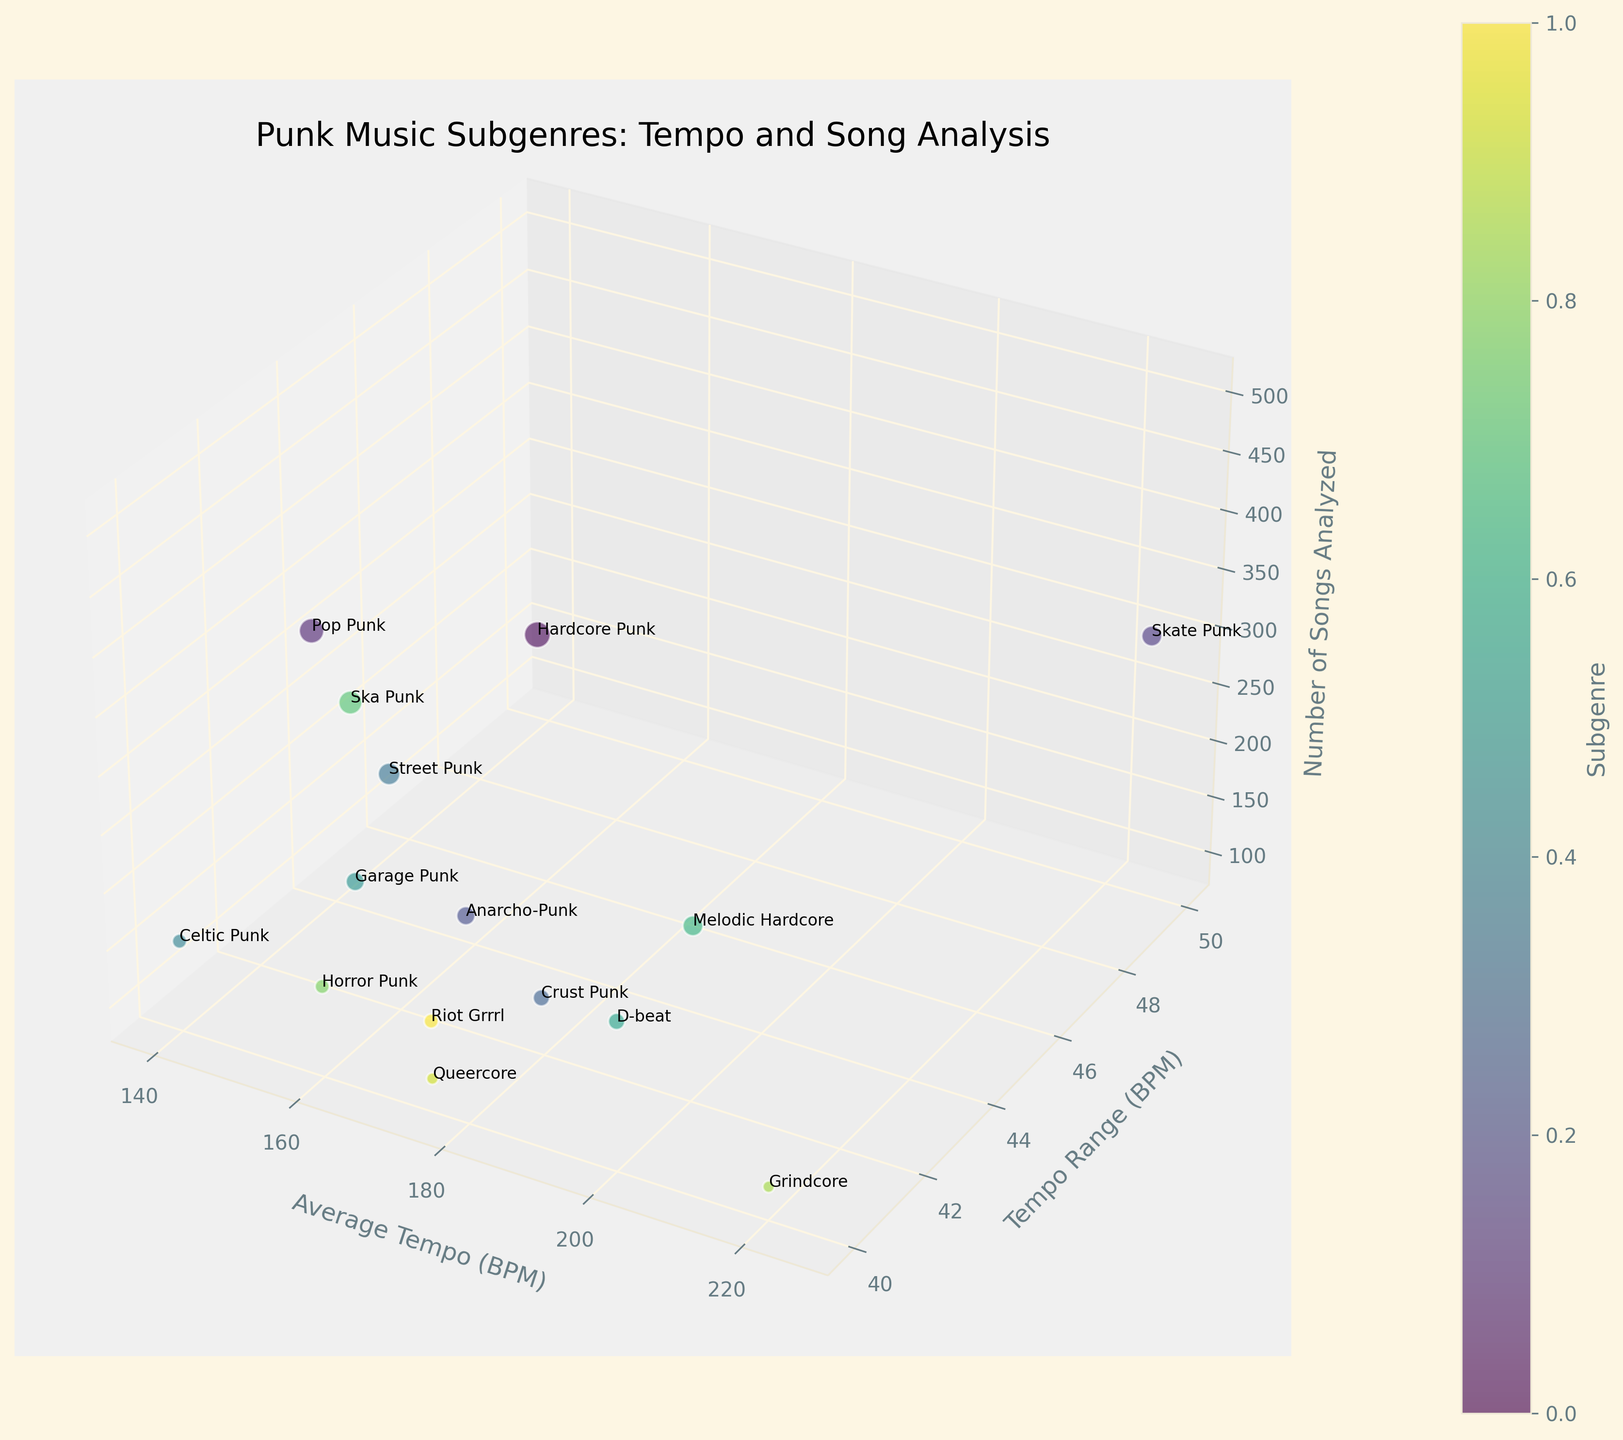How many subgenres are depicted in the chart? Count the number of labeled data points in the 3D bubble chart.
Answer: 15 Which subgenre has the smallest number of songs analyzed? Identify the bubble with the smallest size; the labeled text indicates the subgenre.
Answer: Grindcore What is the average tempo (BPM) for Skate Punk? Locate the label "Skate Punk" and read the corresponding value on the Average Tempo axis.
Answer: 225 What is the tempo range for Pop Punk? Find the "Pop Punk" label and note down the difference between the upper and lower values in the Tempo Range axis.
Answer: 140-180 Which subgenre has the highest tempo range (BPM)? Compare the spread of tempo ranges of each labeled point and identify the maximum range.
Answer: Skate Punk How does the average tempo of Crust Punk compare to D-beat? Identify the average tempos of Crust Punk and D-beat from the Average Tempo axis and compare them.
Answer: Crust Punk: 190, D-beat: 200 Which subgenre from the UK has the highest average tempo? Filter out the subgenres from the UK and compare their average tempos to find the maximum.
Answer: Grindcore If we add the number of songs analyzed for Celtic Punk and Garage Punk, what is the total? Sum the number of songs analyzed for both Celtic Punk and Garage Punk.
Answer: 150 + 250 = 400 Which subgenre has a narrower tempo range: Ska Punk or Riot Grrrl? Look at the tempo ranges of both subgenres and determine which one is narrower.
Answer: Ska Punk (20), Riot Grrrl (40) How many subgenres have an average tempo greater than 180 BPM? Count the number of bubbles whose Average Tempo is above 180 BPM.
Answer: 7 